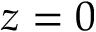Convert formula to latex. <formula><loc_0><loc_0><loc_500><loc_500>z = 0</formula> 